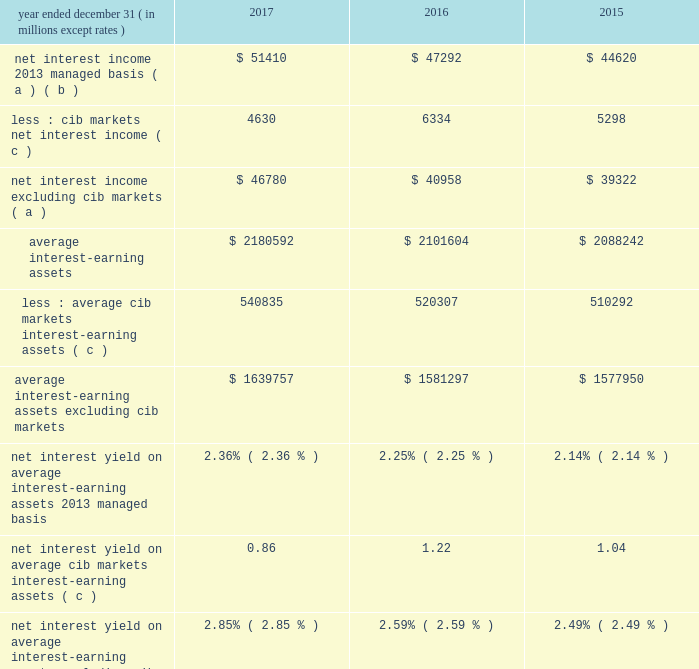Jpmorgan chase & co./2017 annual report 53 net interest income excluding cib 2019s markets businesses in addition to reviewing net interest income on a managed basis , management also reviews net interest income excluding net interest income arising from cib 2019s markets businesses to assess the performance of the firm 2019s lending , investing ( including asset-liability management ) and deposit-raising activities .
This net interest income is referred to as non-markets related net interest income .
Cib 2019s markets businesses are fixed income markets and equity markets .
Management believes that disclosure of non-markets related net interest income provides investors and analysts with another measure by which to analyze the non-markets-related business trends of the firm and provides a comparable measure to other financial institutions that are primarily focused on lending , investing and deposit-raising activities .
The data presented below are non-gaap financial measures due to the exclusion of markets related net interest income arising from cib .
Year ended december 31 , ( in millions , except rates ) 2017 2016 2015 net interest income 2013 managed basis ( a ) ( b ) $ 51410 $ 47292 $ 44620 less : cib markets net interest income ( c ) 4630 6334 5298 net interest income excluding cib markets ( a ) $ 46780 $ 40958 $ 39322 average interest-earning assets $ 2180592 $ 2101604 $ 2088242 less : average cib markets interest-earning assets ( c ) 540835 520307 510292 average interest-earning assets excluding cib markets $ 1639757 $ 1581297 $ 1577950 net interest yield on average interest-earning assets 2013 managed basis 2.36% ( 2.36 % ) 2.25% ( 2.25 % ) 2.14% ( 2.14 % ) net interest yield on average cib markets interest-earning assets ( c ) 0.86 1.22 1.04 net interest yield on average interest-earning assets excluding cib markets 2.85% ( 2.85 % ) 2.59% ( 2.59 % ) 2.49% ( 2.49 % ) ( a ) interest includes the effect of related hedges .
Taxable-equivalent amounts are used where applicable .
( b ) for a reconciliation of net interest income on a reported and managed basis , see reconciliation from the firm 2019s reported u.s .
Gaap results to managed basis on page 52 .
( c ) the amounts in this table differ from the prior-period presentation to align with cib 2019s markets businesses .
For further information on cib 2019s markets businesses , see page 65 .
Calculation of certain u.s .
Gaap and non-gaap financial measures certain u.s .
Gaap and non-gaap financial measures are calculated as follows : book value per share ( 201cbvps 201d ) common stockholders 2019 equity at period-end / common shares at period-end overhead ratio total noninterest expense / total net revenue return on assets ( 201croa 201d ) reported net income / total average assets return on common equity ( 201croe 201d ) net income* / average common stockholders 2019 equity return on tangible common equity ( 201crotce 201d ) net income* / average tangible common equity tangible book value per share ( 201ctbvps 201d ) tangible common equity at period-end / common shares at period-end * represents net income applicable to common equity .
Jpmorgan chase & co./2017 annual report 53 net interest income excluding cib 2019s markets businesses in addition to reviewing net interest income on a managed basis , management also reviews net interest income excluding net interest income arising from cib 2019s markets businesses to assess the performance of the firm 2019s lending , investing ( including asset-liability management ) and deposit-raising activities .
This net interest income is referred to as non-markets related net interest income .
Cib 2019s markets businesses are fixed income markets and equity markets .
Management believes that disclosure of non-markets related net interest income provides investors and analysts with another measure by which to analyze the non-markets-related business trends of the firm and provides a comparable measure to other financial institutions that are primarily focused on lending , investing and deposit-raising activities .
The data presented below are non-gaap financial measures due to the exclusion of markets related net interest income arising from cib .
Year ended december 31 , ( in millions , except rates ) 2017 2016 2015 net interest income 2013 managed basis ( a ) ( b ) $ 51410 $ 47292 $ 44620 less : cib markets net interest income ( c ) 4630 6334 5298 net interest income excluding cib markets ( a ) $ 46780 $ 40958 $ 39322 average interest-earning assets $ 2180592 $ 2101604 $ 2088242 less : average cib markets interest-earning assets ( c ) 540835 520307 510292 average interest-earning assets excluding cib markets $ 1639757 $ 1581297 $ 1577950 net interest yield on average interest-earning assets 2013 managed basis 2.36% ( 2.36 % ) 2.25% ( 2.25 % ) 2.14% ( 2.14 % ) net interest yield on average cib markets interest-earning assets ( c ) 0.86 1.22 1.04 net interest yield on average interest-earning assets excluding cib markets 2.85% ( 2.85 % ) 2.59% ( 2.59 % ) 2.49% ( 2.49 % ) ( a ) interest includes the effect of related hedges .
Taxable-equivalent amounts are used where applicable .
( b ) for a reconciliation of net interest income on a reported and managed basis , see reconciliation from the firm 2019s reported u.s .
Gaap results to managed basis on page 52 .
( c ) the amounts in this table differ from the prior-period presentation to align with cib 2019s markets businesses .
For further information on cib 2019s markets businesses , see page 65 .
Calculation of certain u.s .
Gaap and non-gaap financial measures certain u.s .
Gaap and non-gaap financial measures are calculated as follows : book value per share ( 201cbvps 201d ) common stockholders 2019 equity at period-end / common shares at period-end overhead ratio total noninterest expense / total net revenue return on assets ( 201croa 201d ) reported net income / total average assets return on common equity ( 201croe 201d ) net income* / average common stockholders 2019 equity return on tangible common equity ( 201crotce 201d ) net income* / average tangible common equity tangible book value per share ( 201ctbvps 201d ) tangible common equity at period-end / common shares at period-end * represents net income applicable to common equity .
In 2016 what was the percent of the cib markets net interest income ( c ) as part of the total net interest income 2013 managed basis? 
Computations: (6334 / 47292)
Answer: 0.13393. 